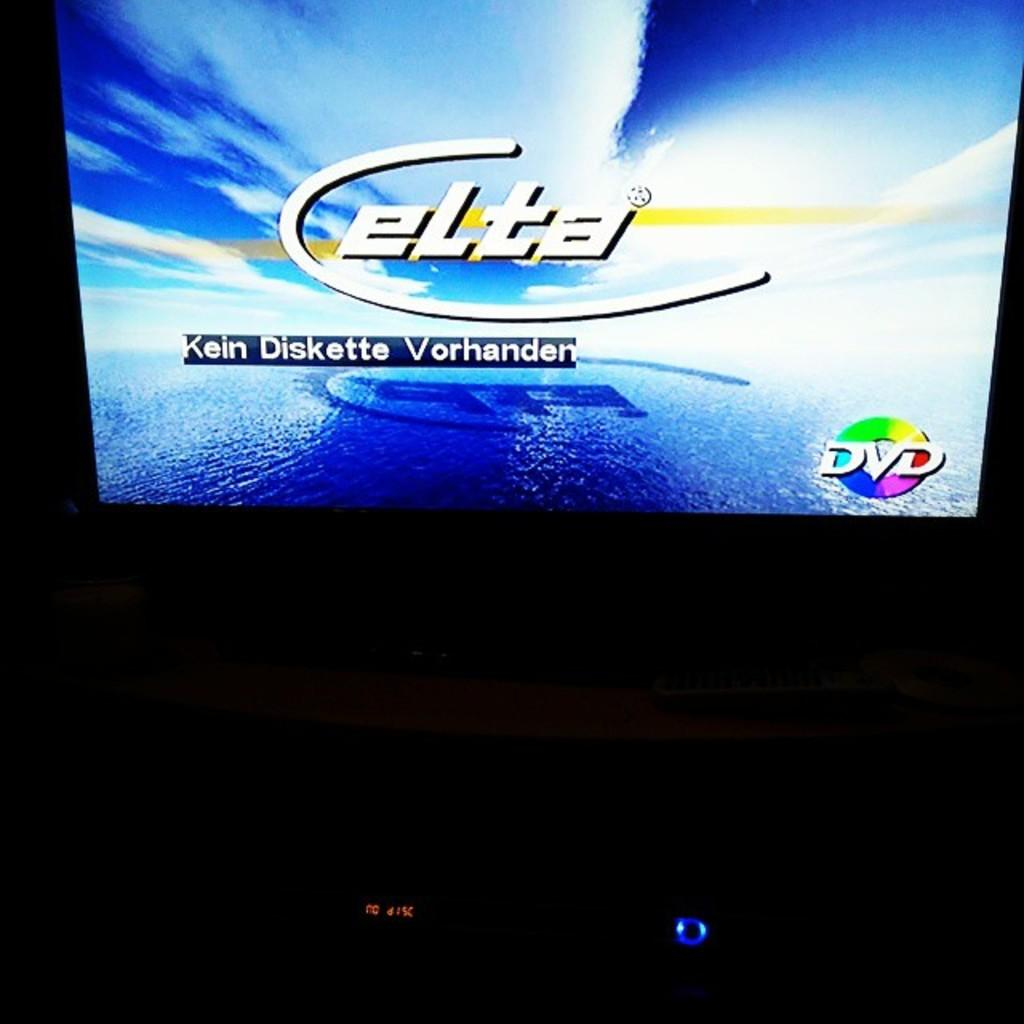<image>
Share a concise interpretation of the image provided. a monitor displaying a dvd by elta kein diskette vorhanden 